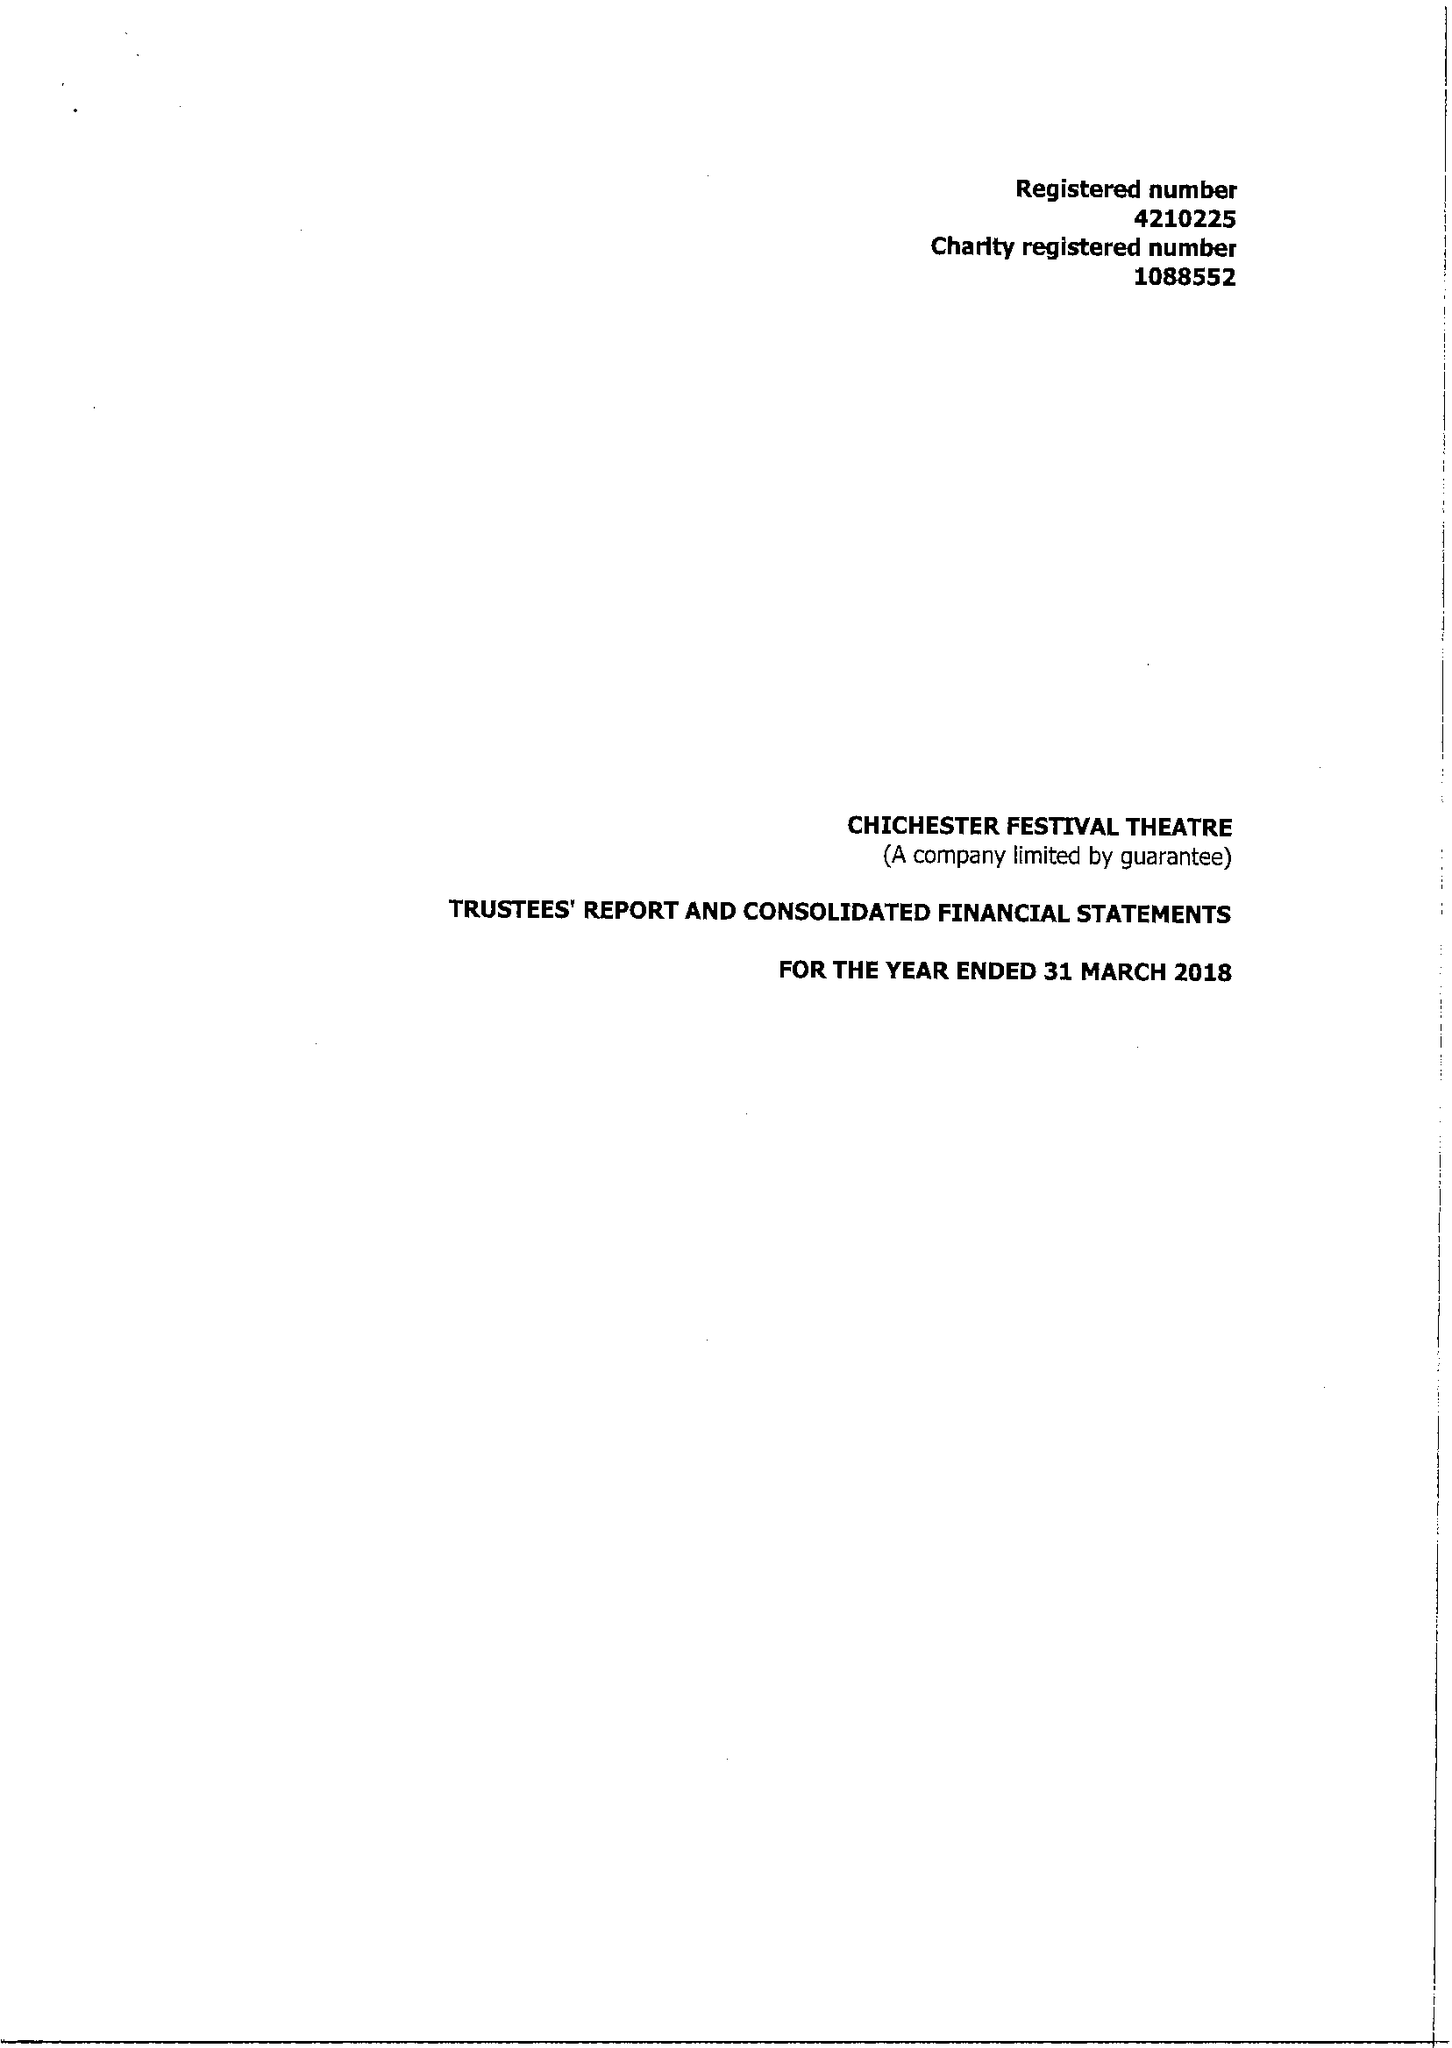What is the value for the report_date?
Answer the question using a single word or phrase. 2018-03-31 